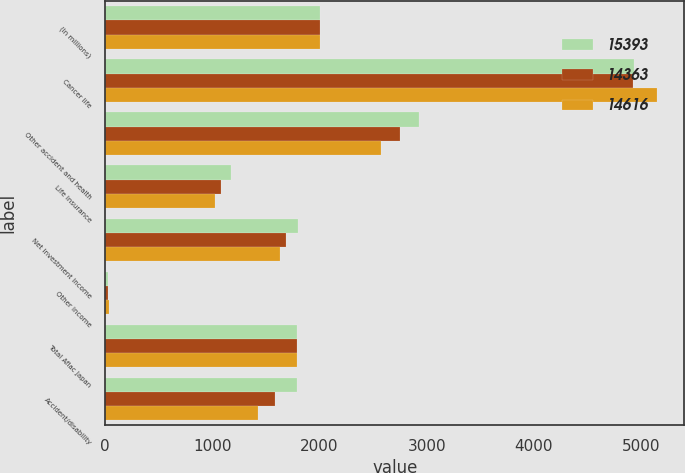<chart> <loc_0><loc_0><loc_500><loc_500><stacked_bar_chart><ecel><fcel>(In millions)<fcel>Cancer life<fcel>Other accident and health<fcel>Life insurance<fcel>Net investment income<fcel>Other income<fcel>Total Aflac Japan<fcel>Accident/disability<nl><fcel>15393<fcel>2007<fcel>4937<fcel>2928<fcel>1172<fcel>1801<fcel>27<fcel>1785<fcel>1785<nl><fcel>14363<fcel>2006<fcel>4923<fcel>2755<fcel>1084<fcel>1688<fcel>25<fcel>1785<fcel>1580<nl><fcel>14616<fcel>2005<fcel>5147<fcel>2577<fcel>1021<fcel>1635<fcel>31<fcel>1785<fcel>1424<nl></chart> 